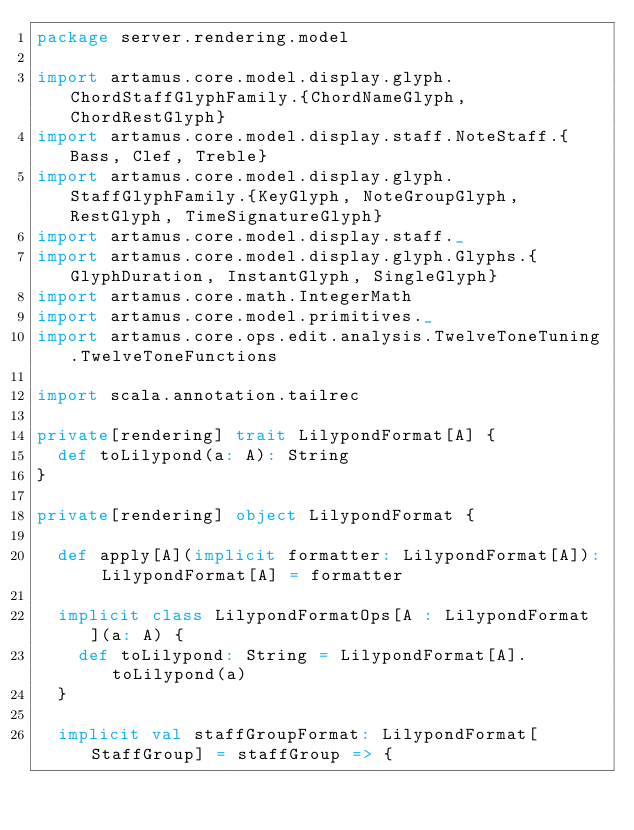Convert code to text. <code><loc_0><loc_0><loc_500><loc_500><_Scala_>package server.rendering.model

import artamus.core.model.display.glyph.ChordStaffGlyphFamily.{ChordNameGlyph, ChordRestGlyph}
import artamus.core.model.display.staff.NoteStaff.{Bass, Clef, Treble}
import artamus.core.model.display.glyph.StaffGlyphFamily.{KeyGlyph, NoteGroupGlyph, RestGlyph, TimeSignatureGlyph}
import artamus.core.model.display.staff._
import artamus.core.model.display.glyph.Glyphs.{GlyphDuration, InstantGlyph, SingleGlyph}
import artamus.core.math.IntegerMath
import artamus.core.model.primitives._
import artamus.core.ops.edit.analysis.TwelveToneTuning.TwelveToneFunctions

import scala.annotation.tailrec

private[rendering] trait LilypondFormat[A] {
  def toLilypond(a: A): String
}

private[rendering] object LilypondFormat {

  def apply[A](implicit formatter: LilypondFormat[A]): LilypondFormat[A] = formatter

  implicit class LilypondFormatOps[A : LilypondFormat](a: A) {
    def toLilypond: String = LilypondFormat[A].toLilypond(a)
  }

  implicit val staffGroupFormat: LilypondFormat[StaffGroup] = staffGroup => {</code> 